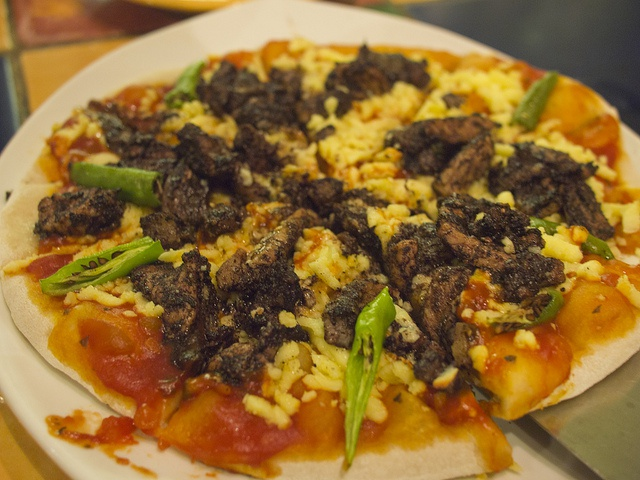Describe the objects in this image and their specific colors. I can see pizza in olive, maroon, and black tones and knife in olive, gray, and black tones in this image. 